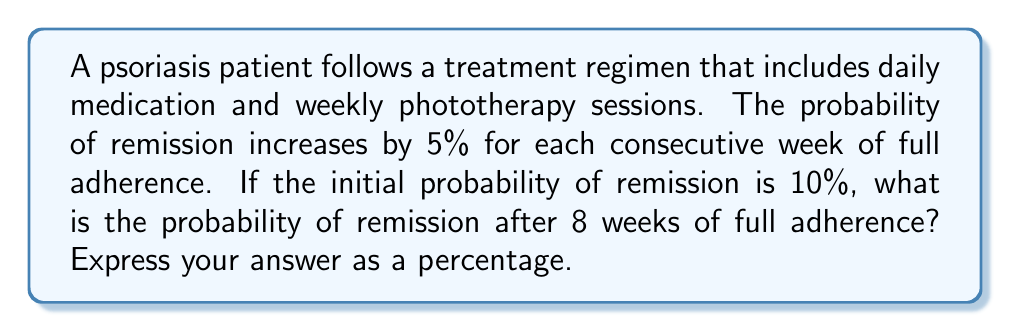Provide a solution to this math problem. Let's approach this step-by-step:

1) We start with an initial probability of remission of 10% or 0.10.

2) Each week of full adherence increases the probability by 5% or 0.05.

3) We need to calculate this increase for 8 consecutive weeks.

4) We can express this as a geometric sequence with:
   - Initial term: $a = 0.10$
   - Common ratio: $r = 1.05$ (because each term is 105% of the previous)
   - Number of terms: $n = 8$

5) The formula for the nth term of a geometric sequence is:
   $$a_n = a \cdot r^{n-1}$$

6) Plugging in our values:
   $$a_8 = 0.10 \cdot (1.05)^{8-1} = 0.10 \cdot (1.05)^7$$

7) Calculate:
   $$a_8 = 0.10 \cdot 1.4071 = 0.14071$$

8) Convert to percentage:
   $$0.14071 \cdot 100\% = 14.071\%$$

Therefore, after 8 weeks of full adherence, the probability of remission is approximately 14.071%.
Answer: 14.071% 